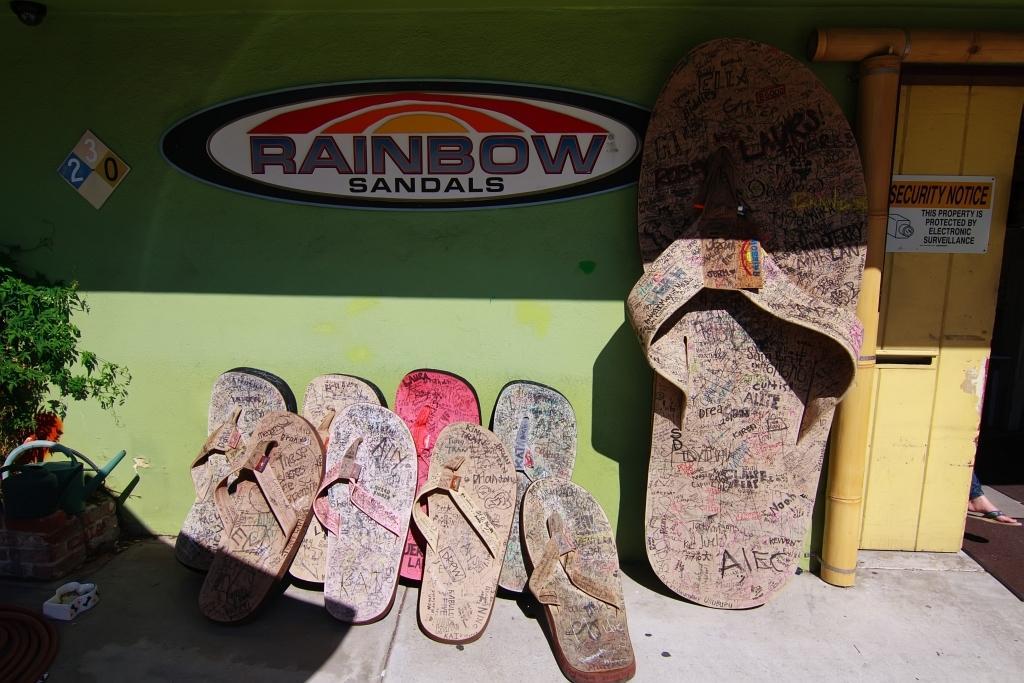Can you describe this image briefly? In this image few slippers are kept near the wall. Left side there are few baskets and a plant. Right side there is a door, behind there is a person leg is visible. 